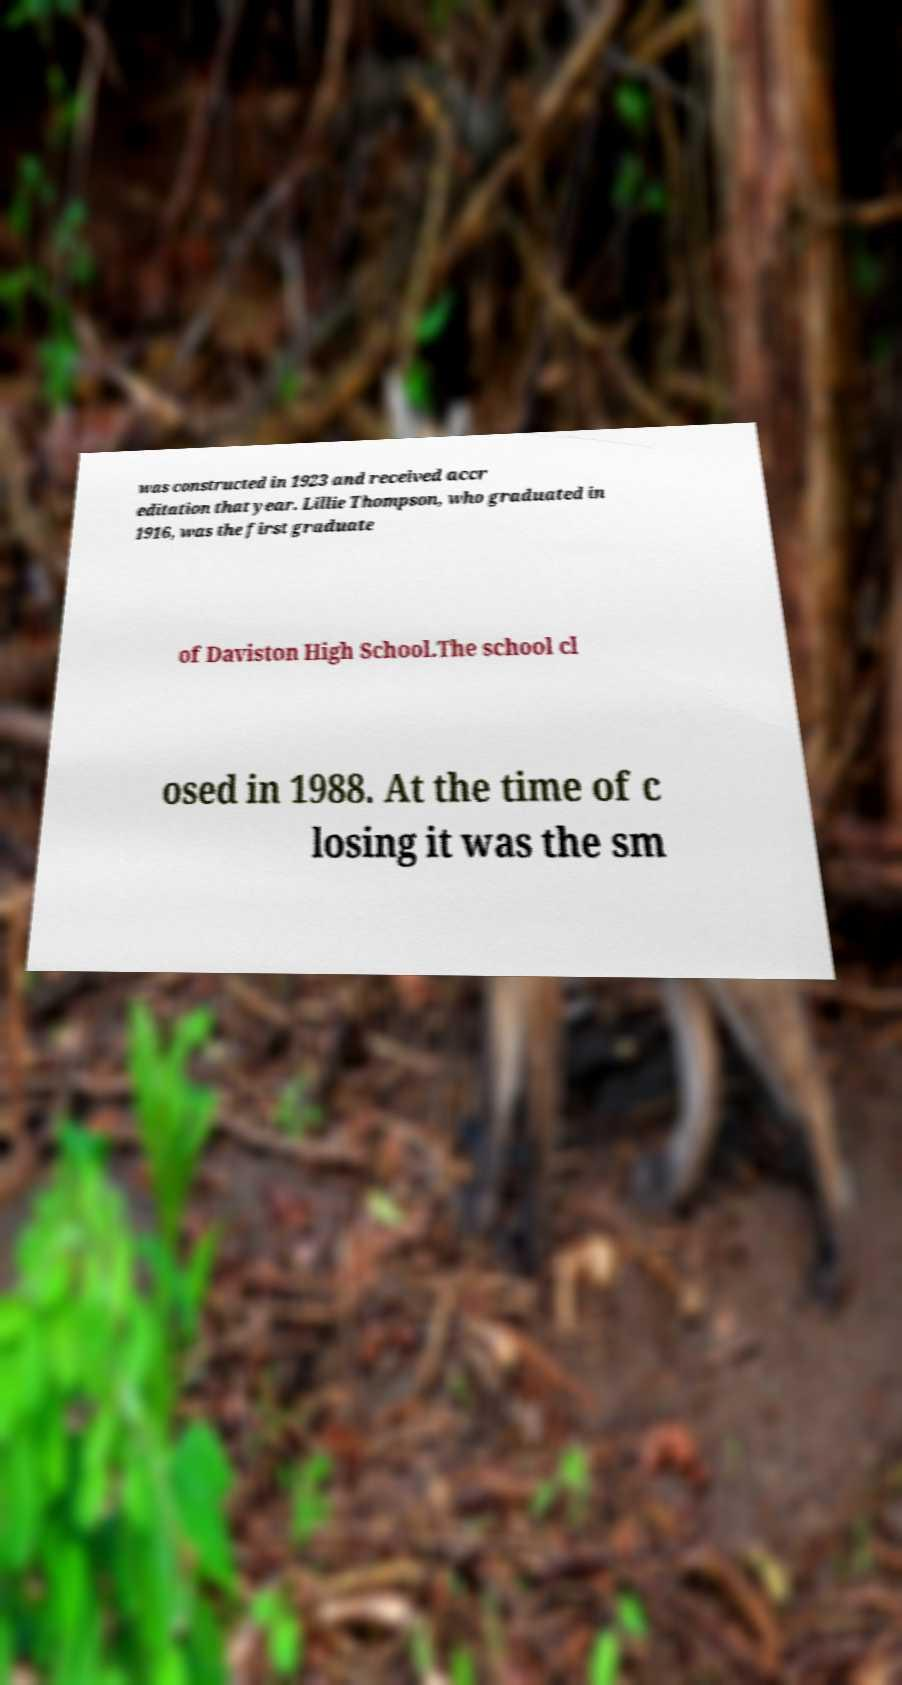For documentation purposes, I need the text within this image transcribed. Could you provide that? was constructed in 1923 and received accr editation that year. Lillie Thompson, who graduated in 1916, was the first graduate of Daviston High School.The school cl osed in 1988. At the time of c losing it was the sm 